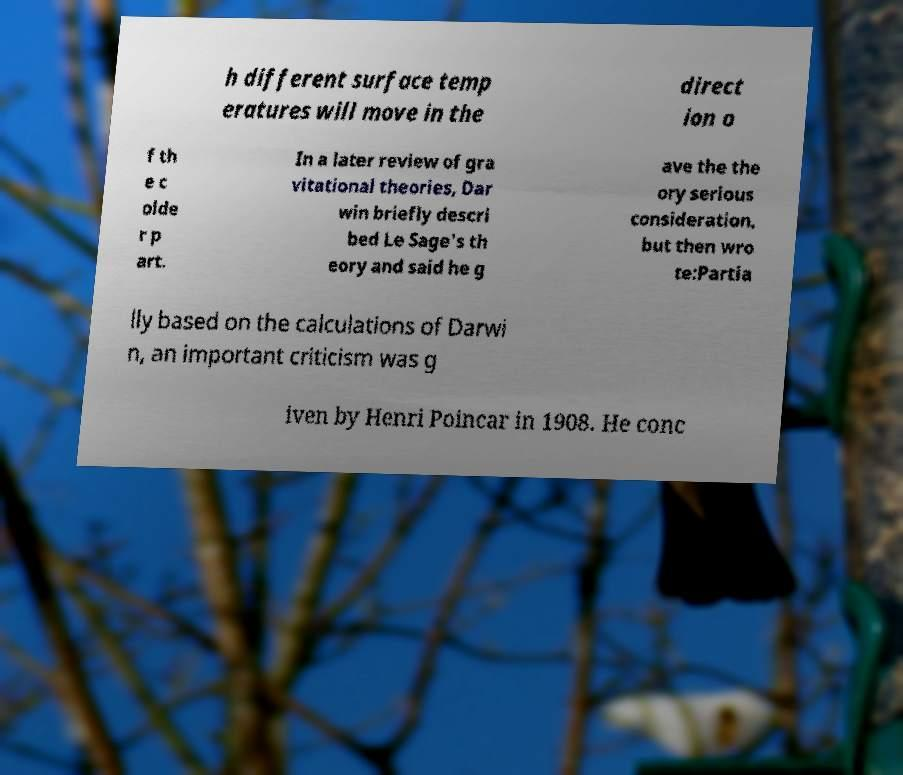Could you extract and type out the text from this image? h different surface temp eratures will move in the direct ion o f th e c olde r p art. In a later review of gra vitational theories, Dar win briefly descri bed Le Sage's th eory and said he g ave the the ory serious consideration, but then wro te:Partia lly based on the calculations of Darwi n, an important criticism was g iven by Henri Poincar in 1908. He conc 